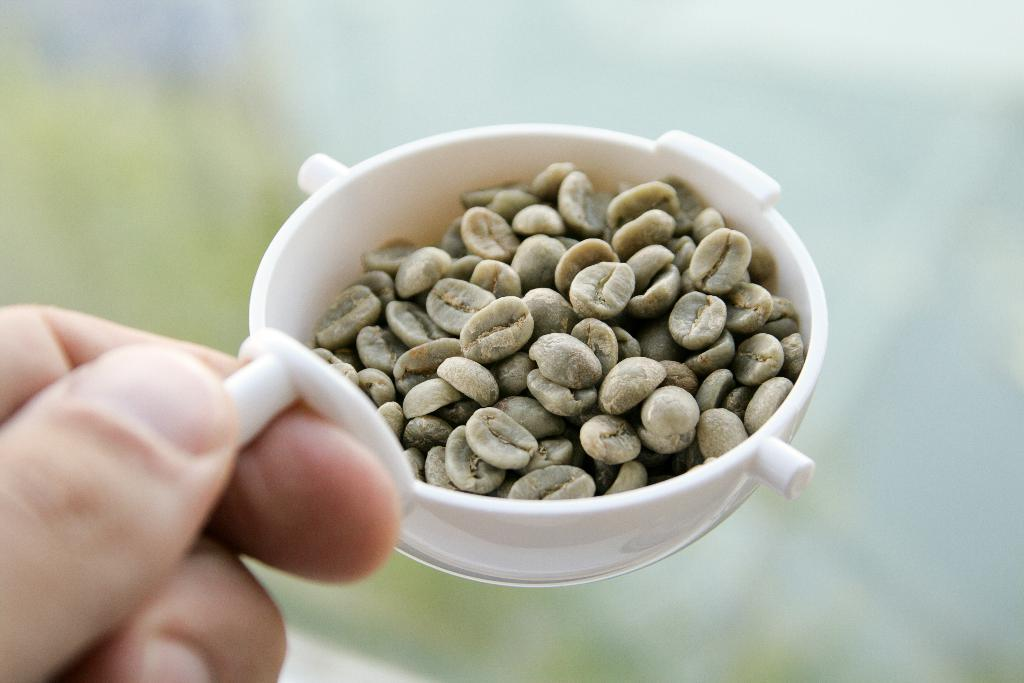Who or what is present in the image? There is a person in the image. What is the person holding in the image? The person is holding a bowl. What is inside the bowl that the person is holding? There are seeds in the bowl. What type of cake is being delivered by the person in the image? There is no cake or delivery mentioned in the image; the person is holding a bowl with seeds in it. 